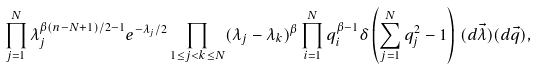<formula> <loc_0><loc_0><loc_500><loc_500>\prod _ { j = 1 } ^ { N } \lambda _ { j } ^ { \beta ( n - N + 1 ) / 2 - 1 } e ^ { - \lambda _ { j } / 2 } \prod _ { 1 \leq j < k \leq N } ( \lambda _ { j } - \lambda _ { k } ) ^ { \beta } \prod _ { i = 1 } ^ { N } q _ { i } ^ { \beta - 1 } \delta \left ( \sum _ { j = 1 } ^ { N } q _ { j } ^ { 2 } - 1 \right ) \, ( d \vec { \lambda } ) ( d \vec { q } ) ,</formula> 